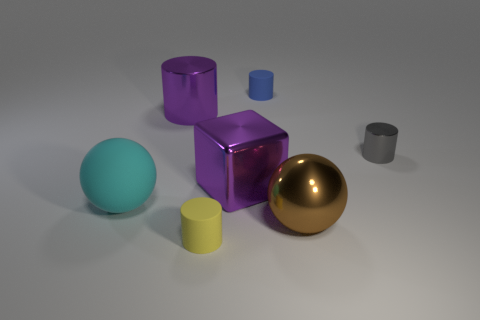There is a brown ball that is the same size as the purple cylinder; what is its material?
Your answer should be compact. Metal. Is the size of the thing in front of the brown thing the same as the blue rubber cylinder?
Your response must be concise. Yes. Do the large metallic object that is to the left of the large metal cube and the blue object have the same shape?
Your response must be concise. Yes. How many objects are big green metallic things or big metallic cubes behind the yellow rubber cylinder?
Your response must be concise. 1. Is the number of big cyan spheres less than the number of large cyan blocks?
Your answer should be compact. No. Is the number of blue things greater than the number of big yellow shiny blocks?
Your answer should be very brief. Yes. How many other things are the same material as the block?
Offer a very short reply. 3. How many small matte cylinders are to the left of the purple object in front of the large purple thing that is to the left of the yellow cylinder?
Offer a very short reply. 1. How many rubber things are brown objects or big green cubes?
Your answer should be very brief. 0. There is a purple object on the left side of the rubber thing in front of the cyan matte sphere; what size is it?
Keep it short and to the point. Large. 